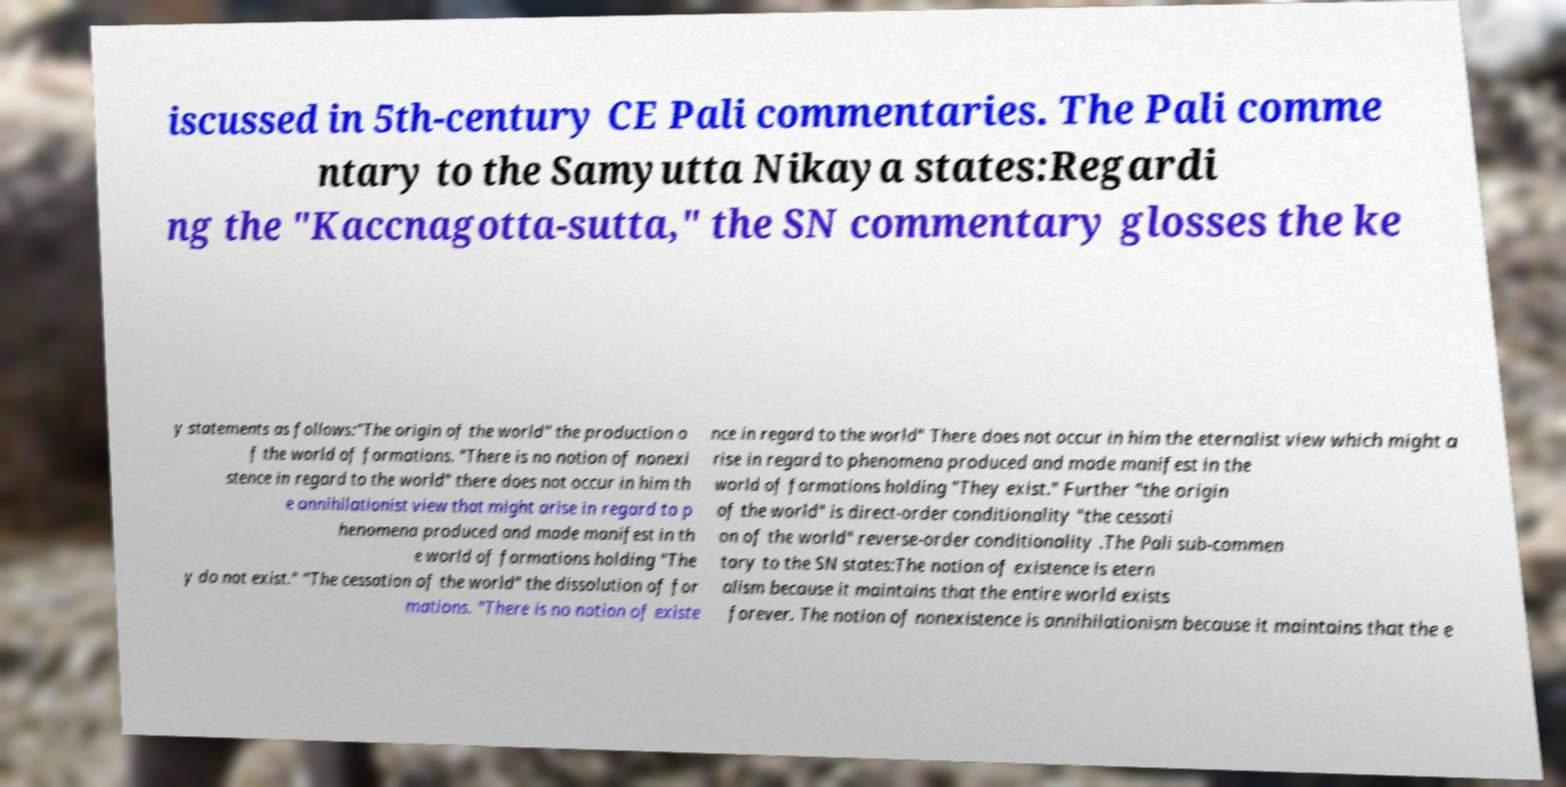Could you assist in decoding the text presented in this image and type it out clearly? iscussed in 5th-century CE Pali commentaries. The Pali comme ntary to the Samyutta Nikaya states:Regardi ng the "Kaccnagotta-sutta," the SN commentary glosses the ke y statements as follows:"The origin of the world" the production o f the world of formations. "There is no notion of nonexi stence in regard to the world" there does not occur in him th e annihilationist view that might arise in regard to p henomena produced and made manifest in th e world of formations holding "The y do not exist." "The cessation of the world" the dissolution of for mations. "There is no notion of existe nce in regard to the world" There does not occur in him the eternalist view which might a rise in regard to phenomena produced and made manifest in the world of formations holding "They exist." Further "the origin of the world" is direct-order conditionality "the cessati on of the world" reverse-order conditionality .The Pali sub-commen tary to the SN states:The notion of existence is etern alism because it maintains that the entire world exists forever. The notion of nonexistence is annihilationism because it maintains that the e 